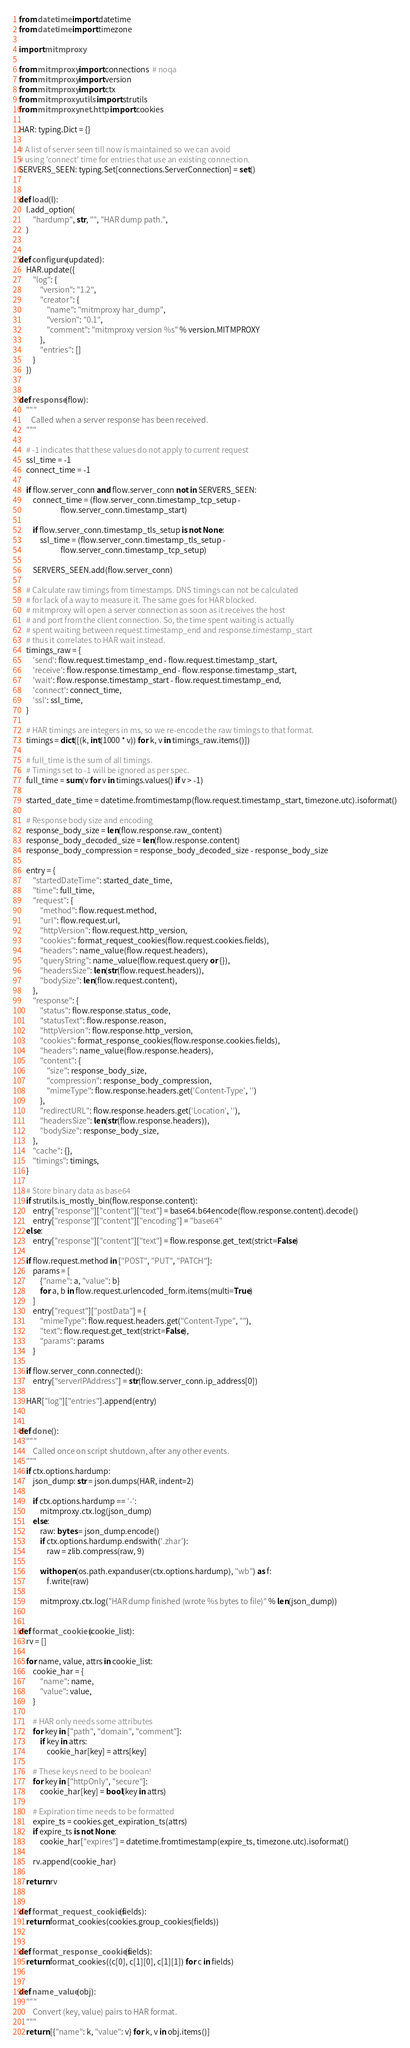<code> <loc_0><loc_0><loc_500><loc_500><_Python_>
from datetime import datetime
from datetime import timezone

import mitmproxy

from mitmproxy import connections  # noqa
from mitmproxy import version
from mitmproxy import ctx
from mitmproxy.utils import strutils
from mitmproxy.net.http import cookies

HAR: typing.Dict = {}

# A list of server seen till now is maintained so we can avoid
# using 'connect' time for entries that use an existing connection.
SERVERS_SEEN: typing.Set[connections.ServerConnection] = set()


def load(l):
    l.add_option(
        "hardump", str, "", "HAR dump path.",
    )


def configure(updated):
    HAR.update({
        "log": {
            "version": "1.2",
            "creator": {
                "name": "mitmproxy har_dump",
                "version": "0.1",
                "comment": "mitmproxy version %s" % version.MITMPROXY
            },
            "entries": []
        }
    })


def response(flow):
    """
       Called when a server response has been received.
    """

    # -1 indicates that these values do not apply to current request
    ssl_time = -1
    connect_time = -1

    if flow.server_conn and flow.server_conn not in SERVERS_SEEN:
        connect_time = (flow.server_conn.timestamp_tcp_setup -
                        flow.server_conn.timestamp_start)

        if flow.server_conn.timestamp_tls_setup is not None:
            ssl_time = (flow.server_conn.timestamp_tls_setup -
                        flow.server_conn.timestamp_tcp_setup)

        SERVERS_SEEN.add(flow.server_conn)

    # Calculate raw timings from timestamps. DNS timings can not be calculated
    # for lack of a way to measure it. The same goes for HAR blocked.
    # mitmproxy will open a server connection as soon as it receives the host
    # and port from the client connection. So, the time spent waiting is actually
    # spent waiting between request.timestamp_end and response.timestamp_start
    # thus it correlates to HAR wait instead.
    timings_raw = {
        'send': flow.request.timestamp_end - flow.request.timestamp_start,
        'receive': flow.response.timestamp_end - flow.response.timestamp_start,
        'wait': flow.response.timestamp_start - flow.request.timestamp_end,
        'connect': connect_time,
        'ssl': ssl_time,
    }

    # HAR timings are integers in ms, so we re-encode the raw timings to that format.
    timings = dict([(k, int(1000 * v)) for k, v in timings_raw.items()])

    # full_time is the sum of all timings.
    # Timings set to -1 will be ignored as per spec.
    full_time = sum(v for v in timings.values() if v > -1)

    started_date_time = datetime.fromtimestamp(flow.request.timestamp_start, timezone.utc).isoformat()

    # Response body size and encoding
    response_body_size = len(flow.response.raw_content)
    response_body_decoded_size = len(flow.response.content)
    response_body_compression = response_body_decoded_size - response_body_size

    entry = {
        "startedDateTime": started_date_time,
        "time": full_time,
        "request": {
            "method": flow.request.method,
            "url": flow.request.url,
            "httpVersion": flow.request.http_version,
            "cookies": format_request_cookies(flow.request.cookies.fields),
            "headers": name_value(flow.request.headers),
            "queryString": name_value(flow.request.query or {}),
            "headersSize": len(str(flow.request.headers)),
            "bodySize": len(flow.request.content),
        },
        "response": {
            "status": flow.response.status_code,
            "statusText": flow.response.reason,
            "httpVersion": flow.response.http_version,
            "cookies": format_response_cookies(flow.response.cookies.fields),
            "headers": name_value(flow.response.headers),
            "content": {
                "size": response_body_size,
                "compression": response_body_compression,
                "mimeType": flow.response.headers.get('Content-Type', '')
            },
            "redirectURL": flow.response.headers.get('Location', ''),
            "headersSize": len(str(flow.response.headers)),
            "bodySize": response_body_size,
        },
        "cache": {},
        "timings": timings,
    }

    # Store binary data as base64
    if strutils.is_mostly_bin(flow.response.content):
        entry["response"]["content"]["text"] = base64.b64encode(flow.response.content).decode()
        entry["response"]["content"]["encoding"] = "base64"
    else:
        entry["response"]["content"]["text"] = flow.response.get_text(strict=False)

    if flow.request.method in ["POST", "PUT", "PATCH"]:
        params = [
            {"name": a, "value": b}
            for a, b in flow.request.urlencoded_form.items(multi=True)
        ]
        entry["request"]["postData"] = {
            "mimeType": flow.request.headers.get("Content-Type", ""),
            "text": flow.request.get_text(strict=False),
            "params": params
        }

    if flow.server_conn.connected():
        entry["serverIPAddress"] = str(flow.server_conn.ip_address[0])

    HAR["log"]["entries"].append(entry)


def done():
    """
        Called once on script shutdown, after any other events.
    """
    if ctx.options.hardump:
        json_dump: str = json.dumps(HAR, indent=2)

        if ctx.options.hardump == '-':
            mitmproxy.ctx.log(json_dump)
        else:
            raw: bytes = json_dump.encode()
            if ctx.options.hardump.endswith('.zhar'):
                raw = zlib.compress(raw, 9)

            with open(os.path.expanduser(ctx.options.hardump), "wb") as f:
                f.write(raw)

            mitmproxy.ctx.log("HAR dump finished (wrote %s bytes to file)" % len(json_dump))


def format_cookies(cookie_list):
    rv = []

    for name, value, attrs in cookie_list:
        cookie_har = {
            "name": name,
            "value": value,
        }

        # HAR only needs some attributes
        for key in ["path", "domain", "comment"]:
            if key in attrs:
                cookie_har[key] = attrs[key]

        # These keys need to be boolean!
        for key in ["httpOnly", "secure"]:
            cookie_har[key] = bool(key in attrs)

        # Expiration time needs to be formatted
        expire_ts = cookies.get_expiration_ts(attrs)
        if expire_ts is not None:
            cookie_har["expires"] = datetime.fromtimestamp(expire_ts, timezone.utc).isoformat()

        rv.append(cookie_har)

    return rv


def format_request_cookies(fields):
    return format_cookies(cookies.group_cookies(fields))


def format_response_cookies(fields):
    return format_cookies((c[0], c[1][0], c[1][1]) for c in fields)


def name_value(obj):
    """
        Convert (key, value) pairs to HAR format.
    """
    return [{"name": k, "value": v} for k, v in obj.items()]
</code> 